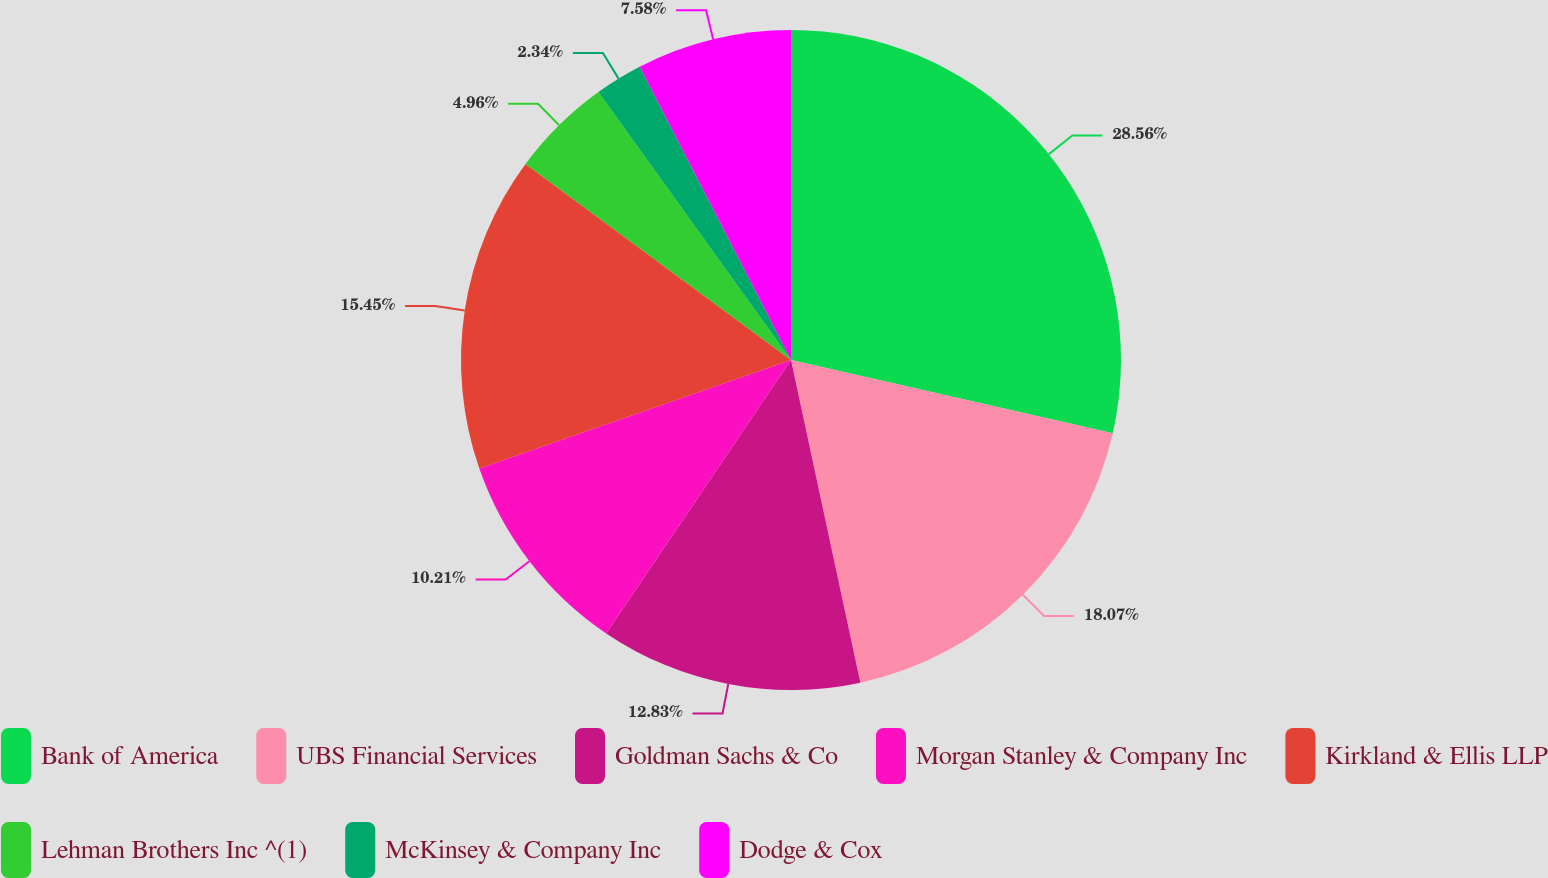<chart> <loc_0><loc_0><loc_500><loc_500><pie_chart><fcel>Bank of America<fcel>UBS Financial Services<fcel>Goldman Sachs & Co<fcel>Morgan Stanley & Company Inc<fcel>Kirkland & Ellis LLP<fcel>Lehman Brothers Inc ^(1)<fcel>McKinsey & Company Inc<fcel>Dodge & Cox<nl><fcel>28.56%<fcel>18.07%<fcel>12.83%<fcel>10.21%<fcel>15.45%<fcel>4.96%<fcel>2.34%<fcel>7.58%<nl></chart> 